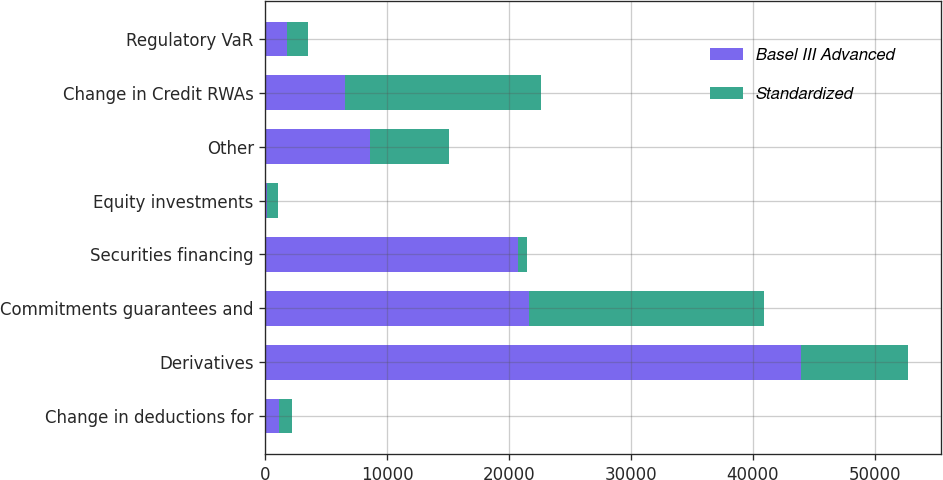<chart> <loc_0><loc_0><loc_500><loc_500><stacked_bar_chart><ecel><fcel>Change in deductions for<fcel>Derivatives<fcel>Commitments guarantees and<fcel>Securities financing<fcel>Equity investments<fcel>Other<fcel>Change in Credit RWAs<fcel>Regulatory VaR<nl><fcel>Basel III Advanced<fcel>1073<fcel>43930<fcel>21608<fcel>20724<fcel>131<fcel>8589<fcel>6510<fcel>1762<nl><fcel>Standardized<fcel>1073<fcel>8830<fcel>19314<fcel>717<fcel>934<fcel>6510<fcel>16138<fcel>1762<nl></chart> 